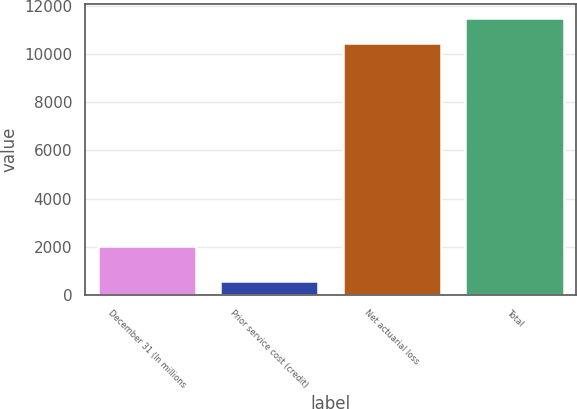Convert chart to OTSL. <chart><loc_0><loc_0><loc_500><loc_500><bar_chart><fcel>December 31 (In millions<fcel>Prior service cost (credit)<fcel>Net actuarial loss<fcel>Total<nl><fcel>2018<fcel>596<fcel>10430<fcel>11473<nl></chart> 